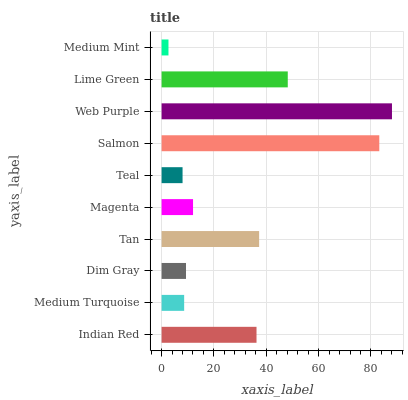Is Medium Mint the minimum?
Answer yes or no. Yes. Is Web Purple the maximum?
Answer yes or no. Yes. Is Medium Turquoise the minimum?
Answer yes or no. No. Is Medium Turquoise the maximum?
Answer yes or no. No. Is Indian Red greater than Medium Turquoise?
Answer yes or no. Yes. Is Medium Turquoise less than Indian Red?
Answer yes or no. Yes. Is Medium Turquoise greater than Indian Red?
Answer yes or no. No. Is Indian Red less than Medium Turquoise?
Answer yes or no. No. Is Indian Red the high median?
Answer yes or no. Yes. Is Magenta the low median?
Answer yes or no. Yes. Is Web Purple the high median?
Answer yes or no. No. Is Dim Gray the low median?
Answer yes or no. No. 